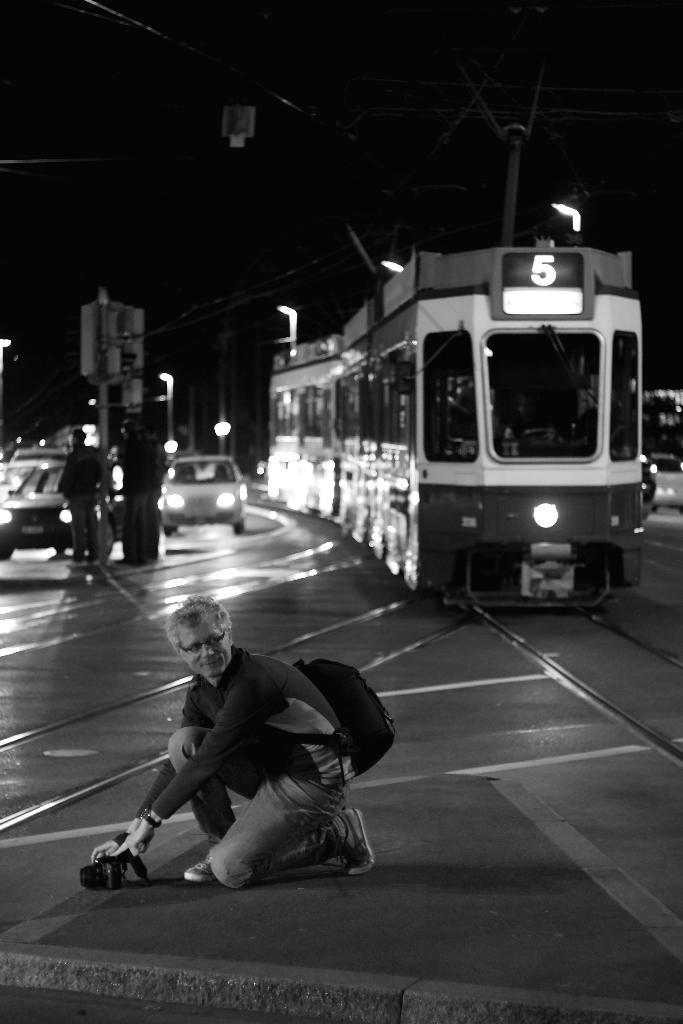Can you describe this image briefly? In front of the image there is a person kneel down by holding a camera in his hand on the surface, behind the person there is a tram and few cars passing on the road and there are pedestrians standing, in the background of the image there are electrical cables, lamp posts and billboards. 